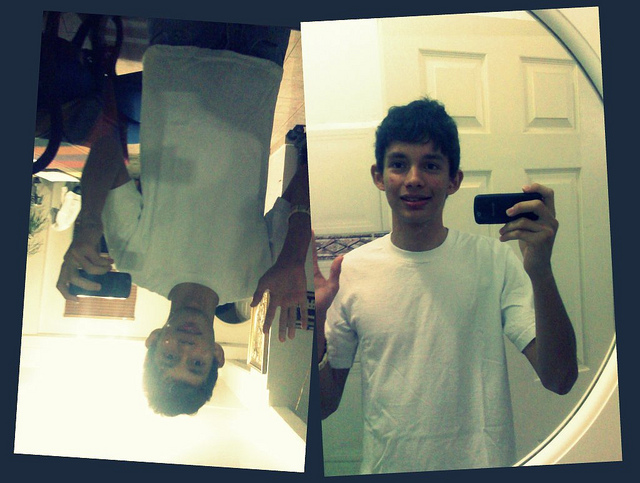How many times does the person appear in the photo? The individual appears twice in the image: once as a direct selfie and once in a reflected, upside-down image in a mirror. 